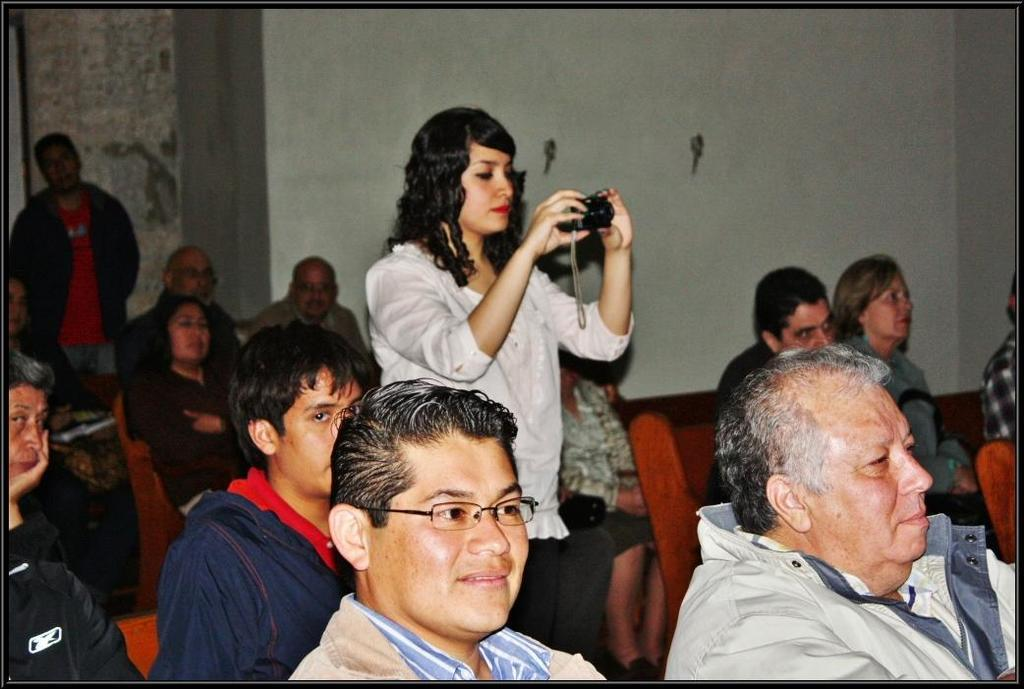What are the people in the image wearing? The people in the image are wearing clothes. What is the person in the middle of the image doing? The person in the middle of the image is holding a camera with her hands. What can be seen in the background of the image? There is a wall in the background of the image. How many lamps are visible in the image? There are no lamps visible in the image. What type of hen can be seen in the image? There are no hens present in the image. 